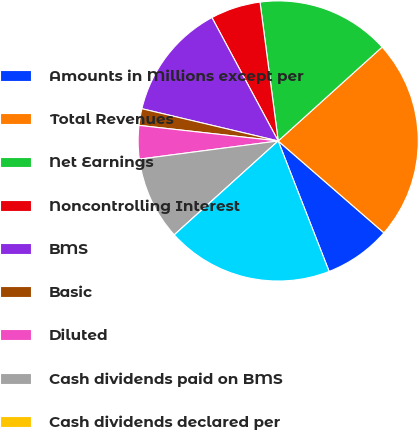Convert chart to OTSL. <chart><loc_0><loc_0><loc_500><loc_500><pie_chart><fcel>Amounts in Millions except per<fcel>Total Revenues<fcel>Net Earnings<fcel>Noncontrolling Interest<fcel>BMS<fcel>Basic<fcel>Diluted<fcel>Cash dividends paid on BMS<fcel>Cash dividends declared per<fcel>Cash and cash equivalents<nl><fcel>7.69%<fcel>23.08%<fcel>15.38%<fcel>5.77%<fcel>13.46%<fcel>1.92%<fcel>3.85%<fcel>9.62%<fcel>0.0%<fcel>19.23%<nl></chart> 